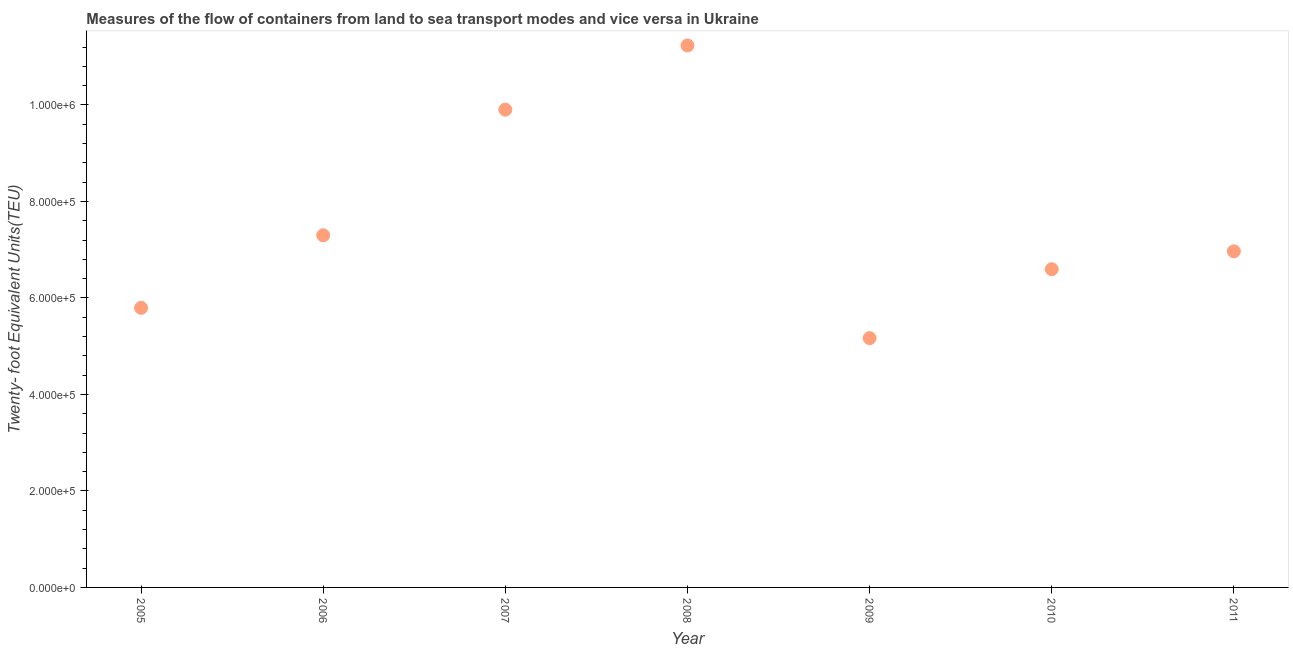What is the container port traffic in 2011?
Your answer should be compact. 6.97e+05. Across all years, what is the maximum container port traffic?
Ensure brevity in your answer.  1.12e+06. Across all years, what is the minimum container port traffic?
Your answer should be compact. 5.17e+05. In which year was the container port traffic maximum?
Your response must be concise. 2008. In which year was the container port traffic minimum?
Offer a terse response. 2009. What is the sum of the container port traffic?
Your answer should be very brief. 5.30e+06. What is the difference between the container port traffic in 2005 and 2011?
Offer a very short reply. -1.17e+05. What is the average container port traffic per year?
Give a very brief answer. 7.57e+05. What is the median container port traffic?
Provide a short and direct response. 6.97e+05. In how many years, is the container port traffic greater than 80000 TEU?
Your answer should be compact. 7. Do a majority of the years between 2010 and 2005 (inclusive) have container port traffic greater than 200000 TEU?
Your answer should be compact. Yes. What is the ratio of the container port traffic in 2007 to that in 2011?
Your answer should be very brief. 1.42. Is the container port traffic in 2007 less than that in 2009?
Offer a terse response. No. Is the difference between the container port traffic in 2008 and 2009 greater than the difference between any two years?
Your answer should be compact. Yes. What is the difference between the highest and the second highest container port traffic?
Provide a short and direct response. 1.33e+05. What is the difference between the highest and the lowest container port traffic?
Keep it short and to the point. 6.07e+05. In how many years, is the container port traffic greater than the average container port traffic taken over all years?
Provide a short and direct response. 2. Does the container port traffic monotonically increase over the years?
Provide a succinct answer. No. How many dotlines are there?
Make the answer very short. 1. How many years are there in the graph?
Provide a short and direct response. 7. What is the title of the graph?
Give a very brief answer. Measures of the flow of containers from land to sea transport modes and vice versa in Ukraine. What is the label or title of the Y-axis?
Offer a terse response. Twenty- foot Equivalent Units(TEU). What is the Twenty- foot Equivalent Units(TEU) in 2005?
Offer a terse response. 5.79e+05. What is the Twenty- foot Equivalent Units(TEU) in 2006?
Your response must be concise. 7.30e+05. What is the Twenty- foot Equivalent Units(TEU) in 2007?
Offer a very short reply. 9.90e+05. What is the Twenty- foot Equivalent Units(TEU) in 2008?
Provide a short and direct response. 1.12e+06. What is the Twenty- foot Equivalent Units(TEU) in 2009?
Ensure brevity in your answer.  5.17e+05. What is the Twenty- foot Equivalent Units(TEU) in 2010?
Your answer should be compact. 6.60e+05. What is the Twenty- foot Equivalent Units(TEU) in 2011?
Offer a very short reply. 6.97e+05. What is the difference between the Twenty- foot Equivalent Units(TEU) in 2005 and 2006?
Ensure brevity in your answer.  -1.50e+05. What is the difference between the Twenty- foot Equivalent Units(TEU) in 2005 and 2007?
Offer a very short reply. -4.11e+05. What is the difference between the Twenty- foot Equivalent Units(TEU) in 2005 and 2008?
Make the answer very short. -5.44e+05. What is the difference between the Twenty- foot Equivalent Units(TEU) in 2005 and 2009?
Give a very brief answer. 6.28e+04. What is the difference between the Twenty- foot Equivalent Units(TEU) in 2005 and 2010?
Provide a short and direct response. -8.01e+04. What is the difference between the Twenty- foot Equivalent Units(TEU) in 2005 and 2011?
Make the answer very short. -1.17e+05. What is the difference between the Twenty- foot Equivalent Units(TEU) in 2006 and 2007?
Provide a succinct answer. -2.60e+05. What is the difference between the Twenty- foot Equivalent Units(TEU) in 2006 and 2008?
Your answer should be compact. -3.94e+05. What is the difference between the Twenty- foot Equivalent Units(TEU) in 2006 and 2009?
Provide a short and direct response. 2.13e+05. What is the difference between the Twenty- foot Equivalent Units(TEU) in 2006 and 2010?
Provide a short and direct response. 7.02e+04. What is the difference between the Twenty- foot Equivalent Units(TEU) in 2006 and 2011?
Your answer should be very brief. 3.31e+04. What is the difference between the Twenty- foot Equivalent Units(TEU) in 2007 and 2008?
Offer a very short reply. -1.33e+05. What is the difference between the Twenty- foot Equivalent Units(TEU) in 2007 and 2009?
Ensure brevity in your answer.  4.74e+05. What is the difference between the Twenty- foot Equivalent Units(TEU) in 2007 and 2010?
Keep it short and to the point. 3.31e+05. What is the difference between the Twenty- foot Equivalent Units(TEU) in 2007 and 2011?
Provide a succinct answer. 2.94e+05. What is the difference between the Twenty- foot Equivalent Units(TEU) in 2008 and 2009?
Your answer should be compact. 6.07e+05. What is the difference between the Twenty- foot Equivalent Units(TEU) in 2008 and 2010?
Give a very brief answer. 4.64e+05. What is the difference between the Twenty- foot Equivalent Units(TEU) in 2008 and 2011?
Offer a terse response. 4.27e+05. What is the difference between the Twenty- foot Equivalent Units(TEU) in 2009 and 2010?
Your response must be concise. -1.43e+05. What is the difference between the Twenty- foot Equivalent Units(TEU) in 2009 and 2011?
Offer a very short reply. -1.80e+05. What is the difference between the Twenty- foot Equivalent Units(TEU) in 2010 and 2011?
Offer a very short reply. -3.71e+04. What is the ratio of the Twenty- foot Equivalent Units(TEU) in 2005 to that in 2006?
Provide a succinct answer. 0.79. What is the ratio of the Twenty- foot Equivalent Units(TEU) in 2005 to that in 2007?
Make the answer very short. 0.58. What is the ratio of the Twenty- foot Equivalent Units(TEU) in 2005 to that in 2008?
Give a very brief answer. 0.52. What is the ratio of the Twenty- foot Equivalent Units(TEU) in 2005 to that in 2009?
Your answer should be very brief. 1.12. What is the ratio of the Twenty- foot Equivalent Units(TEU) in 2005 to that in 2010?
Your answer should be compact. 0.88. What is the ratio of the Twenty- foot Equivalent Units(TEU) in 2005 to that in 2011?
Your answer should be compact. 0.83. What is the ratio of the Twenty- foot Equivalent Units(TEU) in 2006 to that in 2007?
Your answer should be compact. 0.74. What is the ratio of the Twenty- foot Equivalent Units(TEU) in 2006 to that in 2008?
Offer a very short reply. 0.65. What is the ratio of the Twenty- foot Equivalent Units(TEU) in 2006 to that in 2009?
Your answer should be compact. 1.41. What is the ratio of the Twenty- foot Equivalent Units(TEU) in 2006 to that in 2010?
Offer a terse response. 1.11. What is the ratio of the Twenty- foot Equivalent Units(TEU) in 2006 to that in 2011?
Ensure brevity in your answer.  1.05. What is the ratio of the Twenty- foot Equivalent Units(TEU) in 2007 to that in 2008?
Give a very brief answer. 0.88. What is the ratio of the Twenty- foot Equivalent Units(TEU) in 2007 to that in 2009?
Provide a short and direct response. 1.92. What is the ratio of the Twenty- foot Equivalent Units(TEU) in 2007 to that in 2010?
Provide a succinct answer. 1.5. What is the ratio of the Twenty- foot Equivalent Units(TEU) in 2007 to that in 2011?
Your answer should be compact. 1.42. What is the ratio of the Twenty- foot Equivalent Units(TEU) in 2008 to that in 2009?
Give a very brief answer. 2.17. What is the ratio of the Twenty- foot Equivalent Units(TEU) in 2008 to that in 2010?
Provide a short and direct response. 1.7. What is the ratio of the Twenty- foot Equivalent Units(TEU) in 2008 to that in 2011?
Your response must be concise. 1.61. What is the ratio of the Twenty- foot Equivalent Units(TEU) in 2009 to that in 2010?
Your answer should be very brief. 0.78. What is the ratio of the Twenty- foot Equivalent Units(TEU) in 2009 to that in 2011?
Ensure brevity in your answer.  0.74. What is the ratio of the Twenty- foot Equivalent Units(TEU) in 2010 to that in 2011?
Your answer should be very brief. 0.95. 